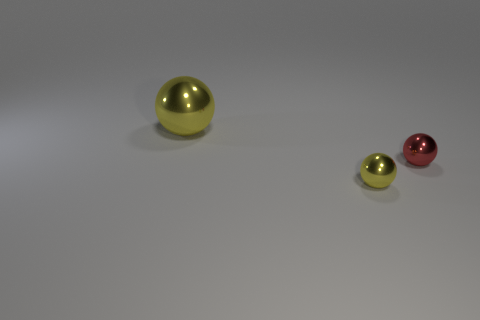What number of large spheres are there? In the image, there is one large sphere that can be observed among the three spheres present. 